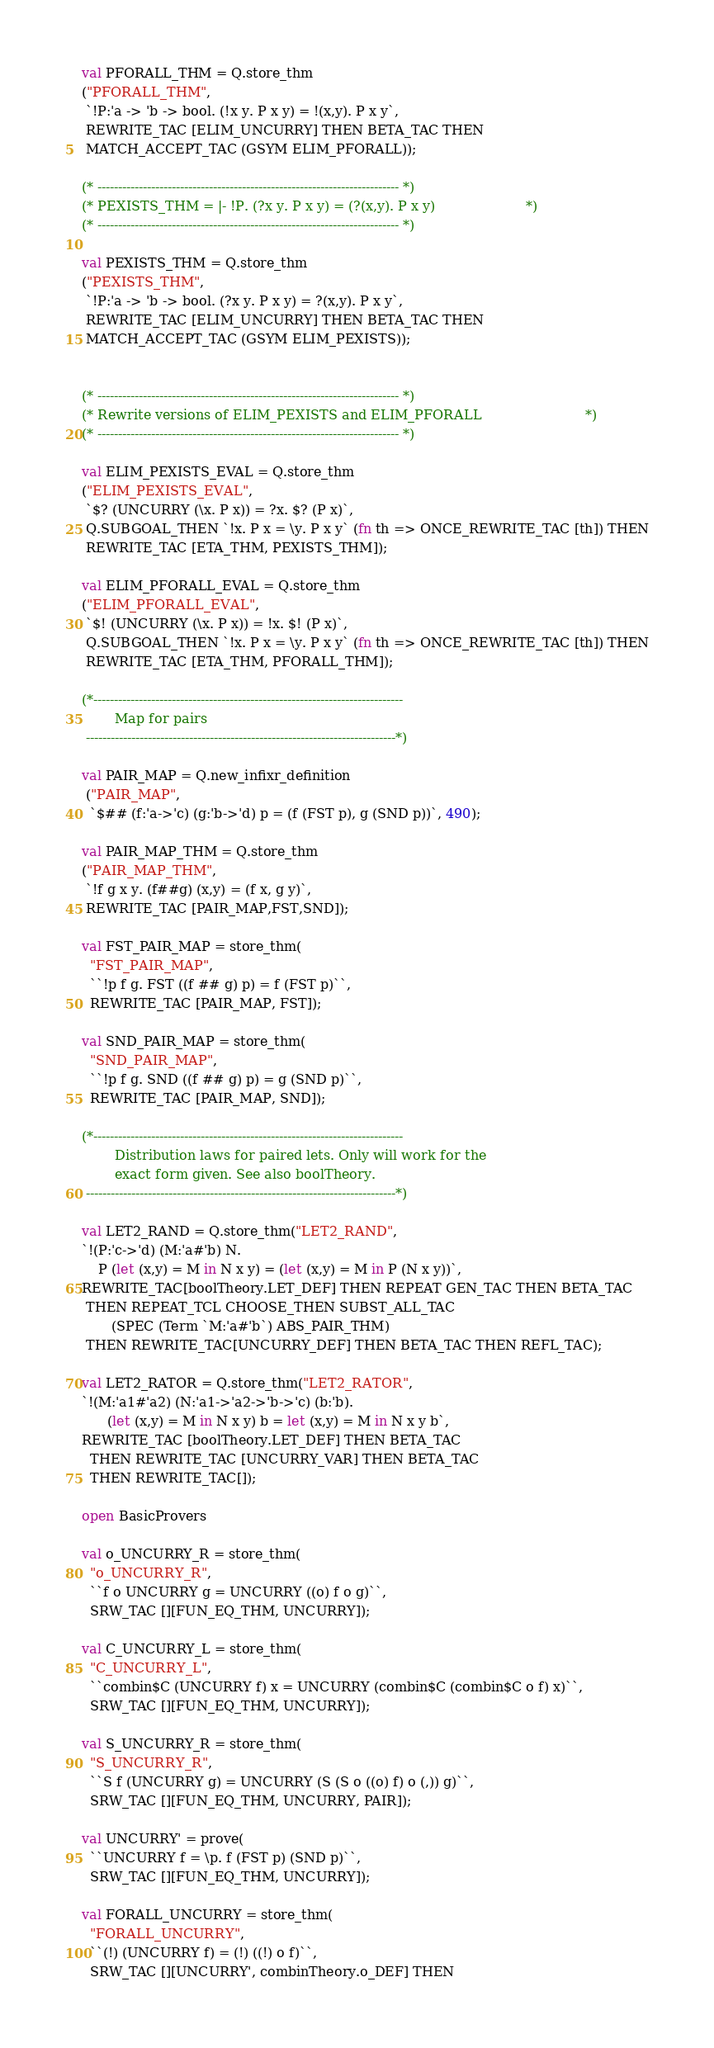<code> <loc_0><loc_0><loc_500><loc_500><_SML_>val PFORALL_THM = Q.store_thm
("PFORALL_THM",
 `!P:'a -> 'b -> bool. (!x y. P x y) = !(x,y). P x y`,
 REWRITE_TAC [ELIM_UNCURRY] THEN BETA_TAC THEN
 MATCH_ACCEPT_TAC (GSYM ELIM_PFORALL));

(* ------------------------------------------------------------------------- *)
(* PEXISTS_THM = |- !P. (?x y. P x y) = (?(x,y). P x y)                      *)
(* ------------------------------------------------------------------------- *)

val PEXISTS_THM = Q.store_thm
("PEXISTS_THM",
 `!P:'a -> 'b -> bool. (?x y. P x y) = ?(x,y). P x y`,
 REWRITE_TAC [ELIM_UNCURRY] THEN BETA_TAC THEN
 MATCH_ACCEPT_TAC (GSYM ELIM_PEXISTS));


(* ------------------------------------------------------------------------- *)
(* Rewrite versions of ELIM_PEXISTS and ELIM_PFORALL                         *)
(* ------------------------------------------------------------------------- *)

val ELIM_PEXISTS_EVAL = Q.store_thm
("ELIM_PEXISTS_EVAL",
 `$? (UNCURRY (\x. P x)) = ?x. $? (P x)`,
 Q.SUBGOAL_THEN `!x. P x = \y. P x y` (fn th => ONCE_REWRITE_TAC [th]) THEN
 REWRITE_TAC [ETA_THM, PEXISTS_THM]);

val ELIM_PFORALL_EVAL = Q.store_thm
("ELIM_PFORALL_EVAL",
 `$! (UNCURRY (\x. P x)) = !x. $! (P x)`,
 Q.SUBGOAL_THEN `!x. P x = \y. P x y` (fn th => ONCE_REWRITE_TAC [th]) THEN
 REWRITE_TAC [ETA_THM, PFORALL_THM]);

(*---------------------------------------------------------------------------
        Map for pairs
 ---------------------------------------------------------------------------*)

val PAIR_MAP = Q.new_infixr_definition
 ("PAIR_MAP",
  `$## (f:'a->'c) (g:'b->'d) p = (f (FST p), g (SND p))`, 490);

val PAIR_MAP_THM = Q.store_thm
("PAIR_MAP_THM",
 `!f g x y. (f##g) (x,y) = (f x, g y)`,
 REWRITE_TAC [PAIR_MAP,FST,SND]);

val FST_PAIR_MAP = store_thm(
  "FST_PAIR_MAP",
  ``!p f g. FST ((f ## g) p) = f (FST p)``,
  REWRITE_TAC [PAIR_MAP, FST]);

val SND_PAIR_MAP = store_thm(
  "SND_PAIR_MAP",
  ``!p f g. SND ((f ## g) p) = g (SND p)``,
  REWRITE_TAC [PAIR_MAP, SND]);

(*---------------------------------------------------------------------------
        Distribution laws for paired lets. Only will work for the
        exact form given. See also boolTheory.
 ---------------------------------------------------------------------------*)

val LET2_RAND = Q.store_thm("LET2_RAND",
`!(P:'c->'d) (M:'a#'b) N.
    P (let (x,y) = M in N x y) = (let (x,y) = M in P (N x y))`,
REWRITE_TAC[boolTheory.LET_DEF] THEN REPEAT GEN_TAC THEN BETA_TAC
 THEN REPEAT_TCL CHOOSE_THEN SUBST_ALL_TAC
       (SPEC (Term `M:'a#'b`) ABS_PAIR_THM)
 THEN REWRITE_TAC[UNCURRY_DEF] THEN BETA_TAC THEN REFL_TAC);

val LET2_RATOR = Q.store_thm("LET2_RATOR",
`!(M:'a1#'a2) (N:'a1->'a2->'b->'c) (b:'b).
      (let (x,y) = M in N x y) b = let (x,y) = M in N x y b`,
REWRITE_TAC [boolTheory.LET_DEF] THEN BETA_TAC
  THEN REWRITE_TAC [UNCURRY_VAR] THEN BETA_TAC
  THEN REWRITE_TAC[]);

open BasicProvers

val o_UNCURRY_R = store_thm(
  "o_UNCURRY_R",
  ``f o UNCURRY g = UNCURRY ((o) f o g)``,
  SRW_TAC [][FUN_EQ_THM, UNCURRY]);

val C_UNCURRY_L = store_thm(
  "C_UNCURRY_L",
  ``combin$C (UNCURRY f) x = UNCURRY (combin$C (combin$C o f) x)``,
  SRW_TAC [][FUN_EQ_THM, UNCURRY]);

val S_UNCURRY_R = store_thm(
  "S_UNCURRY_R",
  ``S f (UNCURRY g) = UNCURRY (S (S o ((o) f) o (,)) g)``,
  SRW_TAC [][FUN_EQ_THM, UNCURRY, PAIR]);

val UNCURRY' = prove(
  ``UNCURRY f = \p. f (FST p) (SND p)``,
  SRW_TAC [][FUN_EQ_THM, UNCURRY]);

val FORALL_UNCURRY = store_thm(
  "FORALL_UNCURRY",
  ``(!) (UNCURRY f) = (!) ((!) o f)``,
  SRW_TAC [][UNCURRY', combinTheory.o_DEF] THEN</code> 